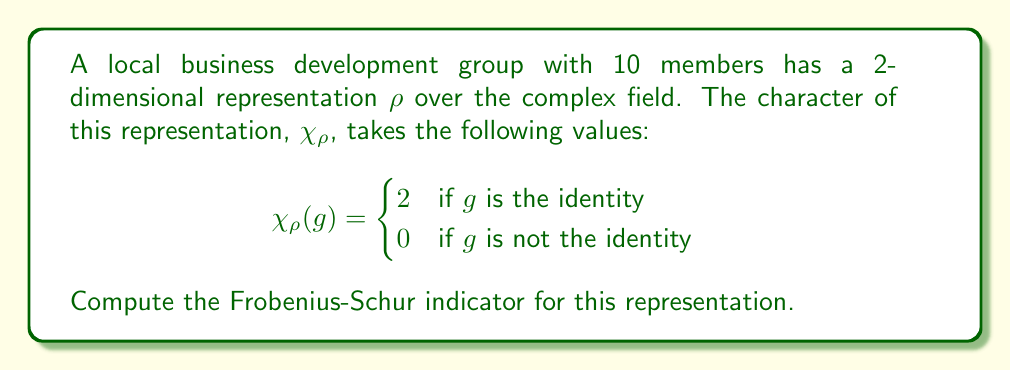Help me with this question. To compute the Frobenius-Schur indicator for the representation $\rho$, we use the formula:

$$\nu(\rho) = \frac{1}{|G|} \sum_{g \in G} \chi_\rho(g^2)$$

Where $|G|$ is the order of the group (in this case, 10) and $g^2$ denotes the square of each group element.

Step 1: Identify the values of $\chi_\rho(g^2)$
- For the identity element $e$, $e^2 = e$, so $\chi_\rho(e^2) = 2$
- For any non-identity element $g$, $g^2$ is also non-identity, so $\chi_\rho(g^2) = 0$

Step 2: Count the occurrences
- There is 1 identity element
- There are 9 non-identity elements

Step 3: Apply the formula
$$\nu(\rho) = \frac{1}{10} (2 + 0 + 0 + 0 + 0 + 0 + 0 + 0 + 0 + 0)$$

Step 4: Simplify
$$\nu(\rho) = \frac{1}{10} \cdot 2 = \frac{1}{5}$$

The Frobenius-Schur indicator for this representation is $\frac{1}{5}$.
Answer: $\frac{1}{5}$ 